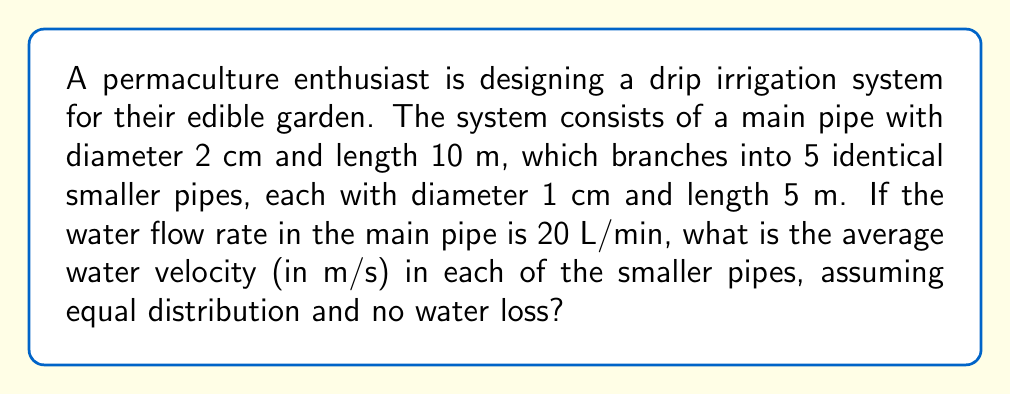Solve this math problem. Let's approach this step-by-step:

1) First, we need to calculate the cross-sectional area of the pipes:
   - Main pipe: $A_m = \pi r^2 = \pi (0.01 \text{ m})^2 = 3.14 \times 10^{-4} \text{ m}^2$
   - Each smaller pipe: $A_s = \pi r^2 = \pi (0.005 \text{ m})^2 = 7.85 \times 10^{-5} \text{ m}^2$

2) The flow rate in the main pipe is given as 20 L/min. Let's convert this to m³/s:
   $Q = 20 \text{ L/min} = \frac{20}{1000 \times 60} \text{ m}^3/\text{s} = 3.33 \times 10^{-4} \text{ m}^3/\text{s}$

3) Assuming equal distribution, each smaller pipe receives 1/5 of the total flow:
   $Q_s = \frac{Q}{5} = \frac{3.33 \times 10^{-4}}{5} = 6.67 \times 10^{-5} \text{ m}^3/\text{s}$

4) We can use the continuity equation to find the velocity in each smaller pipe:
   $Q = A \times v$
   $v = \frac{Q}{A}$

5) Substituting the values for each smaller pipe:
   $v = \frac{6.67 \times 10^{-5} \text{ m}^3/\text{s}}{7.85 \times 10^{-5} \text{ m}^2} = 0.85 \text{ m/s}$

Therefore, the average water velocity in each of the smaller pipes is 0.85 m/s.
Answer: 0.85 m/s 